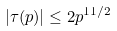Convert formula to latex. <formula><loc_0><loc_0><loc_500><loc_500>| \tau ( p ) | \leq 2 p ^ { 1 1 / 2 }</formula> 